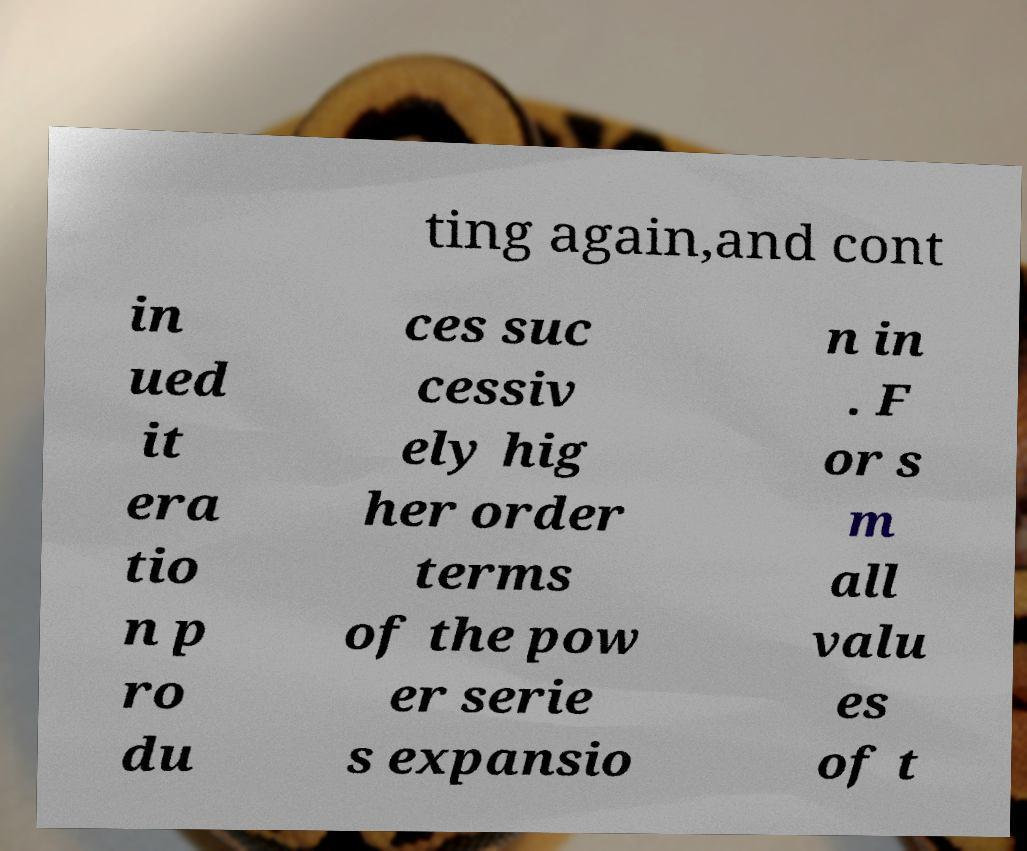I need the written content from this picture converted into text. Can you do that? ting again,and cont in ued it era tio n p ro du ces suc cessiv ely hig her order terms of the pow er serie s expansio n in . F or s m all valu es of t 